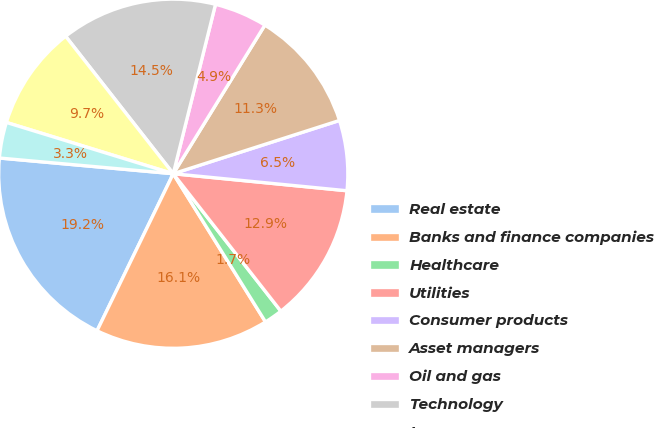<chart> <loc_0><loc_0><loc_500><loc_500><pie_chart><fcel>Real estate<fcel>Banks and finance companies<fcel>Healthcare<fcel>Utilities<fcel>Consumer products<fcel>Asset managers<fcel>Oil and gas<fcel>Technology<fcel>Insurance<fcel>Machinery and equipment<nl><fcel>19.24%<fcel>16.05%<fcel>1.71%<fcel>12.87%<fcel>6.49%<fcel>11.27%<fcel>4.9%<fcel>14.46%<fcel>9.68%<fcel>3.31%<nl></chart> 